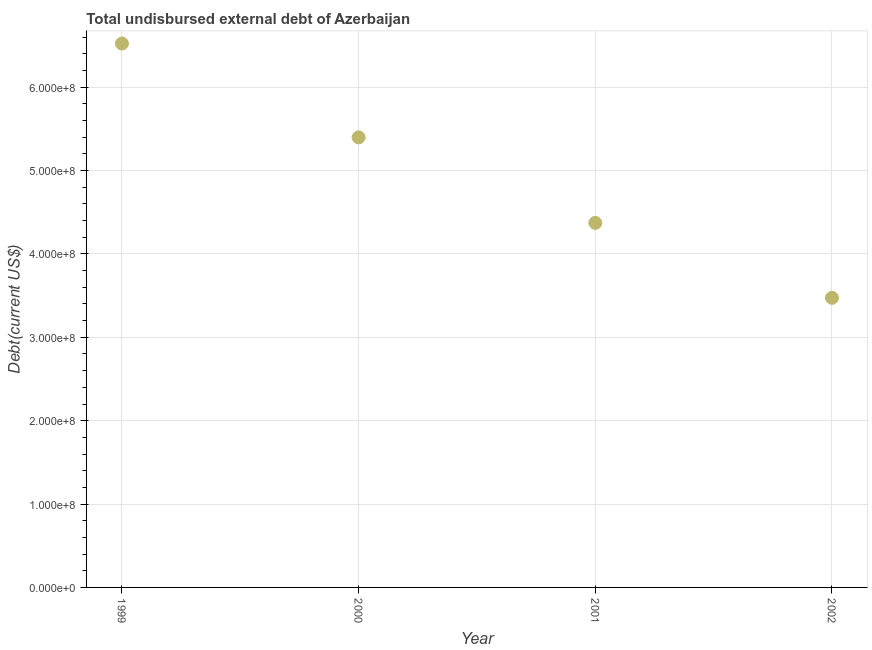What is the total debt in 1999?
Offer a very short reply. 6.52e+08. Across all years, what is the maximum total debt?
Your answer should be compact. 6.52e+08. Across all years, what is the minimum total debt?
Your response must be concise. 3.47e+08. What is the sum of the total debt?
Offer a terse response. 1.98e+09. What is the difference between the total debt in 1999 and 2002?
Keep it short and to the point. 3.05e+08. What is the average total debt per year?
Your response must be concise. 4.94e+08. What is the median total debt?
Provide a short and direct response. 4.89e+08. In how many years, is the total debt greater than 20000000 US$?
Keep it short and to the point. 4. What is the ratio of the total debt in 1999 to that in 2000?
Give a very brief answer. 1.21. Is the difference between the total debt in 1999 and 2001 greater than the difference between any two years?
Provide a succinct answer. No. What is the difference between the highest and the second highest total debt?
Your answer should be very brief. 1.13e+08. What is the difference between the highest and the lowest total debt?
Your response must be concise. 3.05e+08. Does the total debt monotonically increase over the years?
Make the answer very short. No. How many dotlines are there?
Your response must be concise. 1. What is the title of the graph?
Provide a succinct answer. Total undisbursed external debt of Azerbaijan. What is the label or title of the X-axis?
Provide a short and direct response. Year. What is the label or title of the Y-axis?
Provide a short and direct response. Debt(current US$). What is the Debt(current US$) in 1999?
Make the answer very short. 6.52e+08. What is the Debt(current US$) in 2000?
Your answer should be compact. 5.40e+08. What is the Debt(current US$) in 2001?
Give a very brief answer. 4.37e+08. What is the Debt(current US$) in 2002?
Provide a short and direct response. 3.47e+08. What is the difference between the Debt(current US$) in 1999 and 2000?
Give a very brief answer. 1.13e+08. What is the difference between the Debt(current US$) in 1999 and 2001?
Keep it short and to the point. 2.15e+08. What is the difference between the Debt(current US$) in 1999 and 2002?
Your response must be concise. 3.05e+08. What is the difference between the Debt(current US$) in 2000 and 2001?
Your answer should be very brief. 1.03e+08. What is the difference between the Debt(current US$) in 2000 and 2002?
Your answer should be very brief. 1.92e+08. What is the difference between the Debt(current US$) in 2001 and 2002?
Make the answer very short. 8.99e+07. What is the ratio of the Debt(current US$) in 1999 to that in 2000?
Your answer should be compact. 1.21. What is the ratio of the Debt(current US$) in 1999 to that in 2001?
Make the answer very short. 1.49. What is the ratio of the Debt(current US$) in 1999 to that in 2002?
Provide a short and direct response. 1.88. What is the ratio of the Debt(current US$) in 2000 to that in 2001?
Make the answer very short. 1.23. What is the ratio of the Debt(current US$) in 2000 to that in 2002?
Give a very brief answer. 1.55. What is the ratio of the Debt(current US$) in 2001 to that in 2002?
Offer a very short reply. 1.26. 